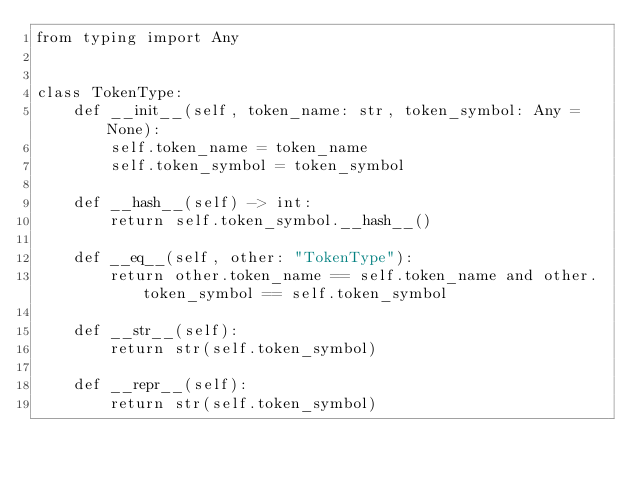<code> <loc_0><loc_0><loc_500><loc_500><_Python_>from typing import Any


class TokenType:
    def __init__(self, token_name: str, token_symbol: Any = None):
        self.token_name = token_name
        self.token_symbol = token_symbol

    def __hash__(self) -> int:
        return self.token_symbol.__hash__()

    def __eq__(self, other: "TokenType"):
        return other.token_name == self.token_name and other.token_symbol == self.token_symbol

    def __str__(self):
        return str(self.token_symbol)

    def __repr__(self):
        return str(self.token_symbol)
</code> 